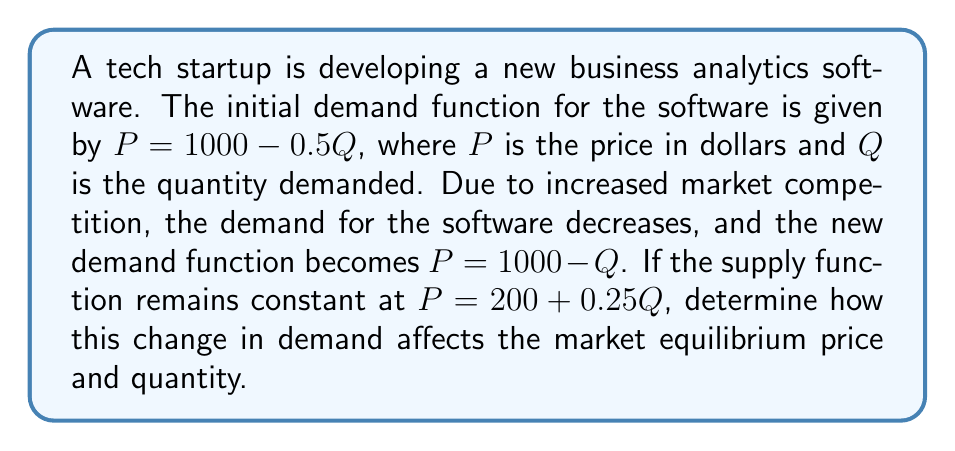Help me with this question. To solve this problem, we need to find the market equilibrium before and after the change in demand. We'll do this in steps:

1. Initial equilibrium:
   Set the initial demand function equal to the supply function:
   $1000 - 0.5Q = 200 + 0.25Q$
   $800 = 0.75Q$
   $Q = 1066.67$
   
   Substitute this quantity into either function to find the equilibrium price:
   $P = 1000 - 0.5(1066.67) = 466.67$

   Initial equilibrium: $(Q, P) = (1066.67, 466.67)$

2. New equilibrium:
   Set the new demand function equal to the supply function:
   $1000 - Q = 200 + 0.25Q$
   $800 = 1.25Q$
   $Q = 640$
   
   Substitute this quantity into either function to find the new equilibrium price:
   $P = 1000 - 640 = 360$

   New equilibrium: $(Q, P) = (640, 360)$

3. Calculate the changes:
   Change in quantity: $640 - 1066.67 = -426.67$
   Change in price: $360 - 466.67 = -106.67$

The negative values indicate decreases in both equilibrium quantity and price.
Answer: The change in demand results in a decrease of 426.67 units in equilibrium quantity and a decrease of $106.67 in equilibrium price. 